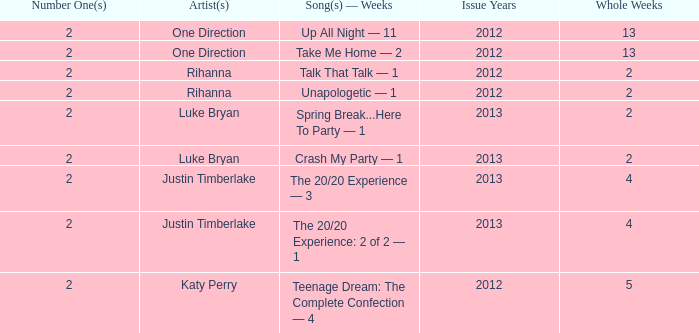For each song by one direction, what is the title and the number of weeks it was at the top of the charts? Up All Night — 11, Take Me Home — 2. 